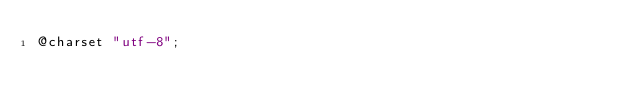<code> <loc_0><loc_0><loc_500><loc_500><_CSS_>@charset "utf-8";


</code> 